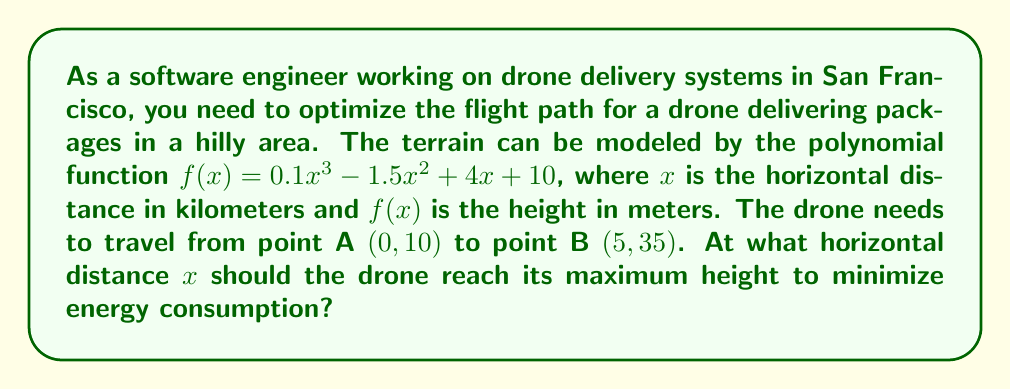Could you help me with this problem? To solve this problem, we need to follow these steps:

1) First, we need to find the derivative of the function $f(x)$ to determine where the maximum height occurs:

   $f'(x) = 0.3x^2 - 3x + 4$

2) The maximum height will occur at the point where $f'(x) = 0$. So, we need to solve the quadratic equation:

   $0.3x^2 - 3x + 4 = 0$

3) We can solve this using the quadratic formula: $x = \frac{-b \pm \sqrt{b^2 - 4ac}}{2a}$

   Where $a = 0.3$, $b = -3$, and $c = 4$

4) Plugging these values into the quadratic formula:

   $x = \frac{3 \pm \sqrt{9 - 4.8}}{0.6} = \frac{3 \pm \sqrt{4.2}}{0.6}$

5) Simplifying:

   $x = \frac{3 \pm 2.05}{0.6}$

6) This gives us two solutions:

   $x_1 = \frac{3 + 2.05}{0.6} \approx 8.42$
   $x_2 = \frac{3 - 2.05}{0.6} \approx 1.58$

7) Since the drone is traveling from x = 0 to x = 5, the solution x ≈ 1.58 is the only one within our range.

Therefore, the drone should reach its maximum height at approximately 1.58 kilometers from the starting point.
Answer: The drone should reach its maximum height at approximately 1.58 kilometers from the starting point. 